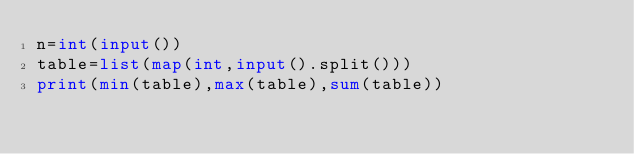<code> <loc_0><loc_0><loc_500><loc_500><_Python_>n=int(input())
table=list(map(int,input().split()))
print(min(table),max(table),sum(table))



</code> 